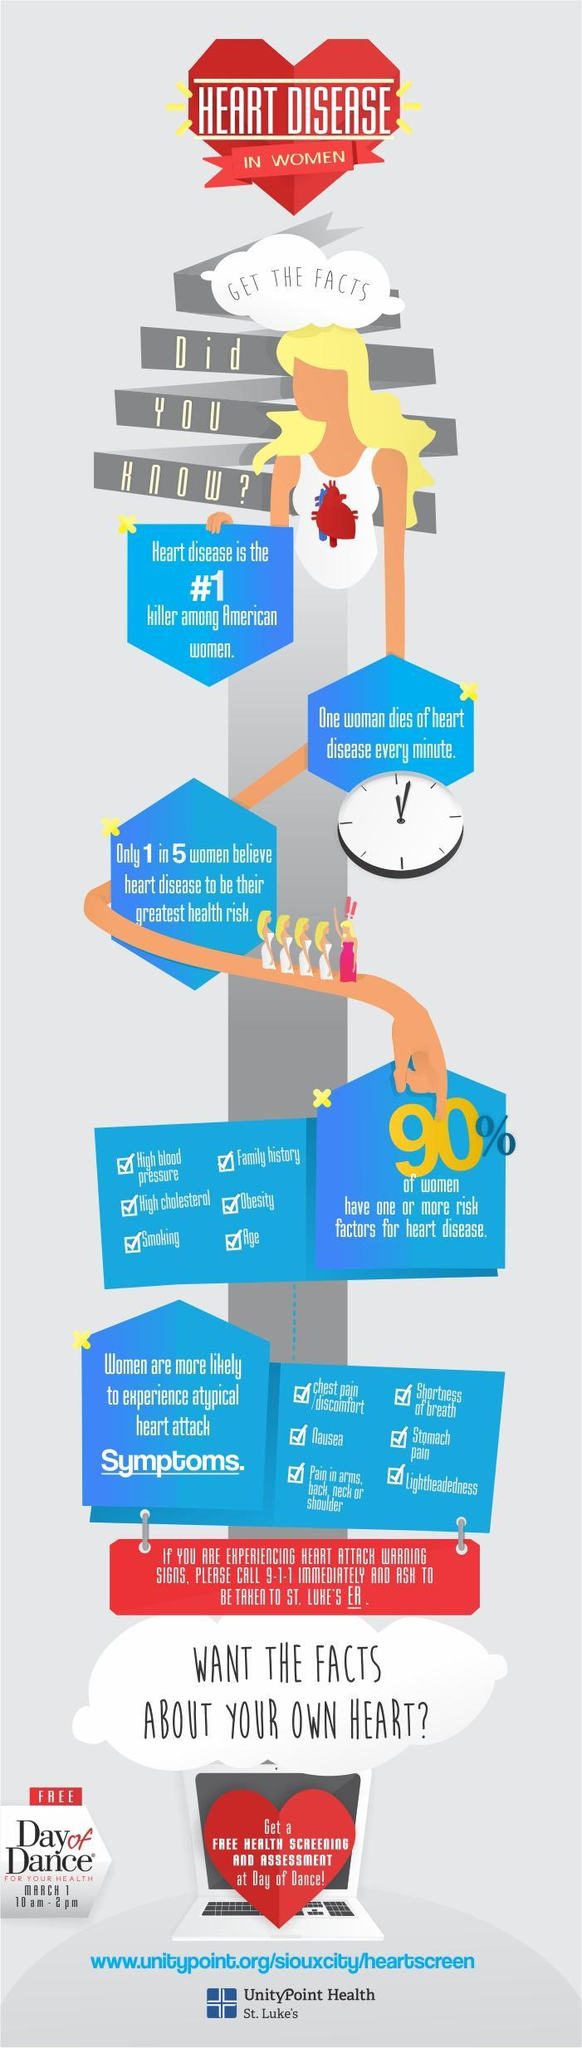How many risk factors for heart disease are mentioned?
Answer the question with a short phrase. 6 What 'percentage' of women believe heart disease to be their greatest health risk? 20% How many women die of heart disease every "hour"? 60 What percentage of the women have 1 or more risk factors for heart disease for heart disease? 90% How many symptoms of heart attack are mentioned? 6 